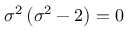Convert formula to latex. <formula><loc_0><loc_0><loc_500><loc_500>\sigma ^ { 2 } \left ( \sigma ^ { 2 } - 2 \right ) = 0</formula> 